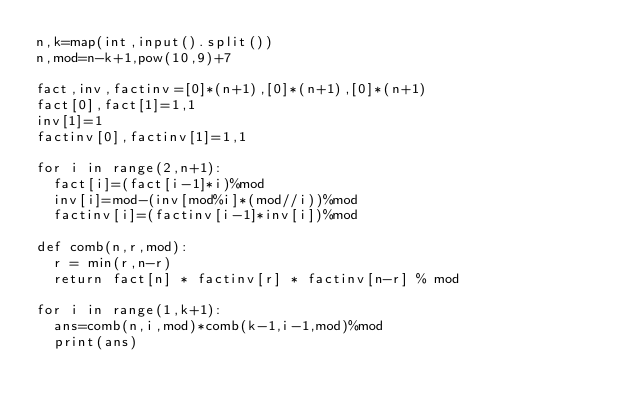<code> <loc_0><loc_0><loc_500><loc_500><_Python_>n,k=map(int,input().split())
n,mod=n-k+1,pow(10,9)+7

fact,inv,factinv=[0]*(n+1),[0]*(n+1),[0]*(n+1)
fact[0],fact[1]=1,1
inv[1]=1
factinv[0],factinv[1]=1,1

for i in range(2,n+1):
  fact[i]=(fact[i-1]*i)%mod
  inv[i]=mod-(inv[mod%i]*(mod//i))%mod               
  factinv[i]=(factinv[i-1]*inv[i])%mod      
    
def comb(n,r,mod):
  r = min(r,n-r)
  return fact[n] * factinv[r] * factinv[n-r] % mod
  
for i in range(1,k+1):
  ans=comb(n,i,mod)*comb(k-1,i-1,mod)%mod
  print(ans)</code> 